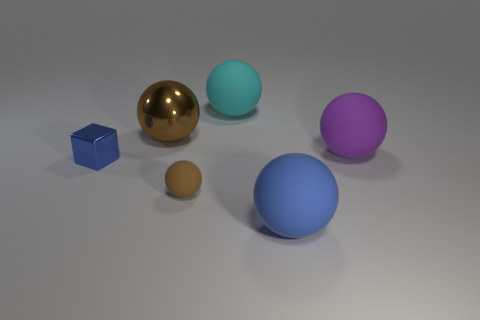Subtract all cyan spheres. How many spheres are left? 4 Subtract all brown shiny balls. How many balls are left? 4 Subtract all gray balls. Subtract all purple cylinders. How many balls are left? 5 Add 3 tiny cyan things. How many objects exist? 9 Subtract all blocks. How many objects are left? 5 Subtract 1 cyan balls. How many objects are left? 5 Subtract all large brown objects. Subtract all small brown things. How many objects are left? 4 Add 5 matte spheres. How many matte spheres are left? 9 Add 1 small brown balls. How many small brown balls exist? 2 